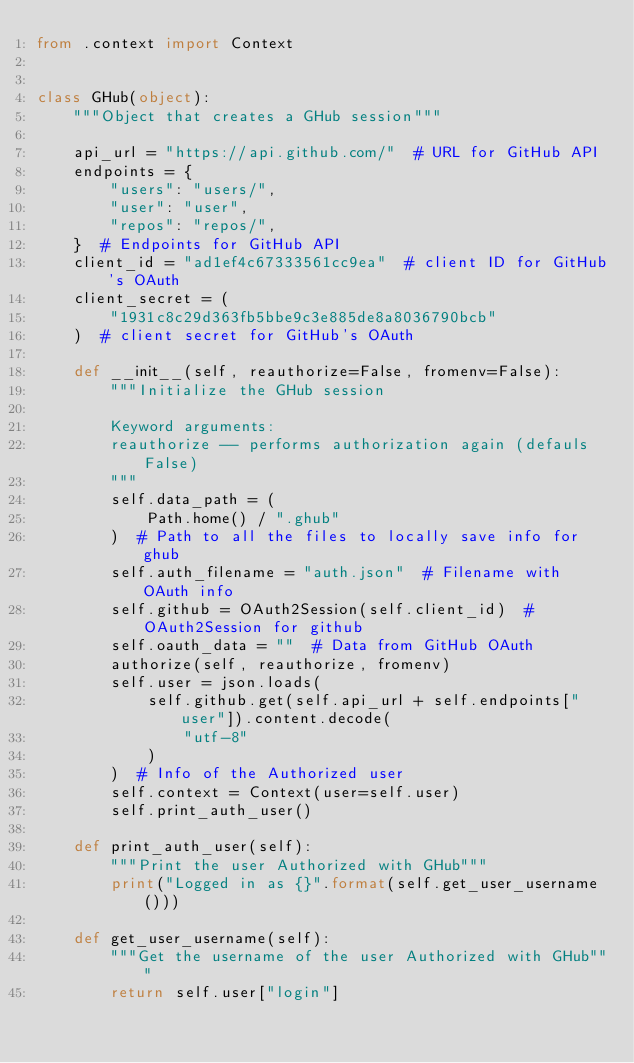Convert code to text. <code><loc_0><loc_0><loc_500><loc_500><_Python_>from .context import Context


class GHub(object):
    """Object that creates a GHub session"""

    api_url = "https://api.github.com/"  # URL for GitHub API
    endpoints = {
        "users": "users/",
        "user": "user",
        "repos": "repos/",
    }  # Endpoints for GitHub API
    client_id = "ad1ef4c67333561cc9ea"  # client ID for GitHub's OAuth
    client_secret = (
        "1931c8c29d363fb5bbe9c3e885de8a8036790bcb"
    )  # client secret for GitHub's OAuth

    def __init__(self, reauthorize=False, fromenv=False):
        """Initialize the GHub session

        Keyword arguments:
        reauthorize -- performs authorization again (defauls False)
        """
        self.data_path = (
            Path.home() / ".ghub"
        )  # Path to all the files to locally save info for ghub
        self.auth_filename = "auth.json"  # Filename with OAuth info
        self.github = OAuth2Session(self.client_id)  # OAuth2Session for github
        self.oauth_data = ""  # Data from GitHub OAuth
        authorize(self, reauthorize, fromenv)
        self.user = json.loads(
            self.github.get(self.api_url + self.endpoints["user"]).content.decode(
                "utf-8"
            )
        )  # Info of the Authorized user
        self.context = Context(user=self.user)
        self.print_auth_user()

    def print_auth_user(self):
        """Print the user Authorized with GHub"""
        print("Logged in as {}".format(self.get_user_username()))

    def get_user_username(self):
        """Get the username of the user Authorized with GHub"""
        return self.user["login"]
</code> 